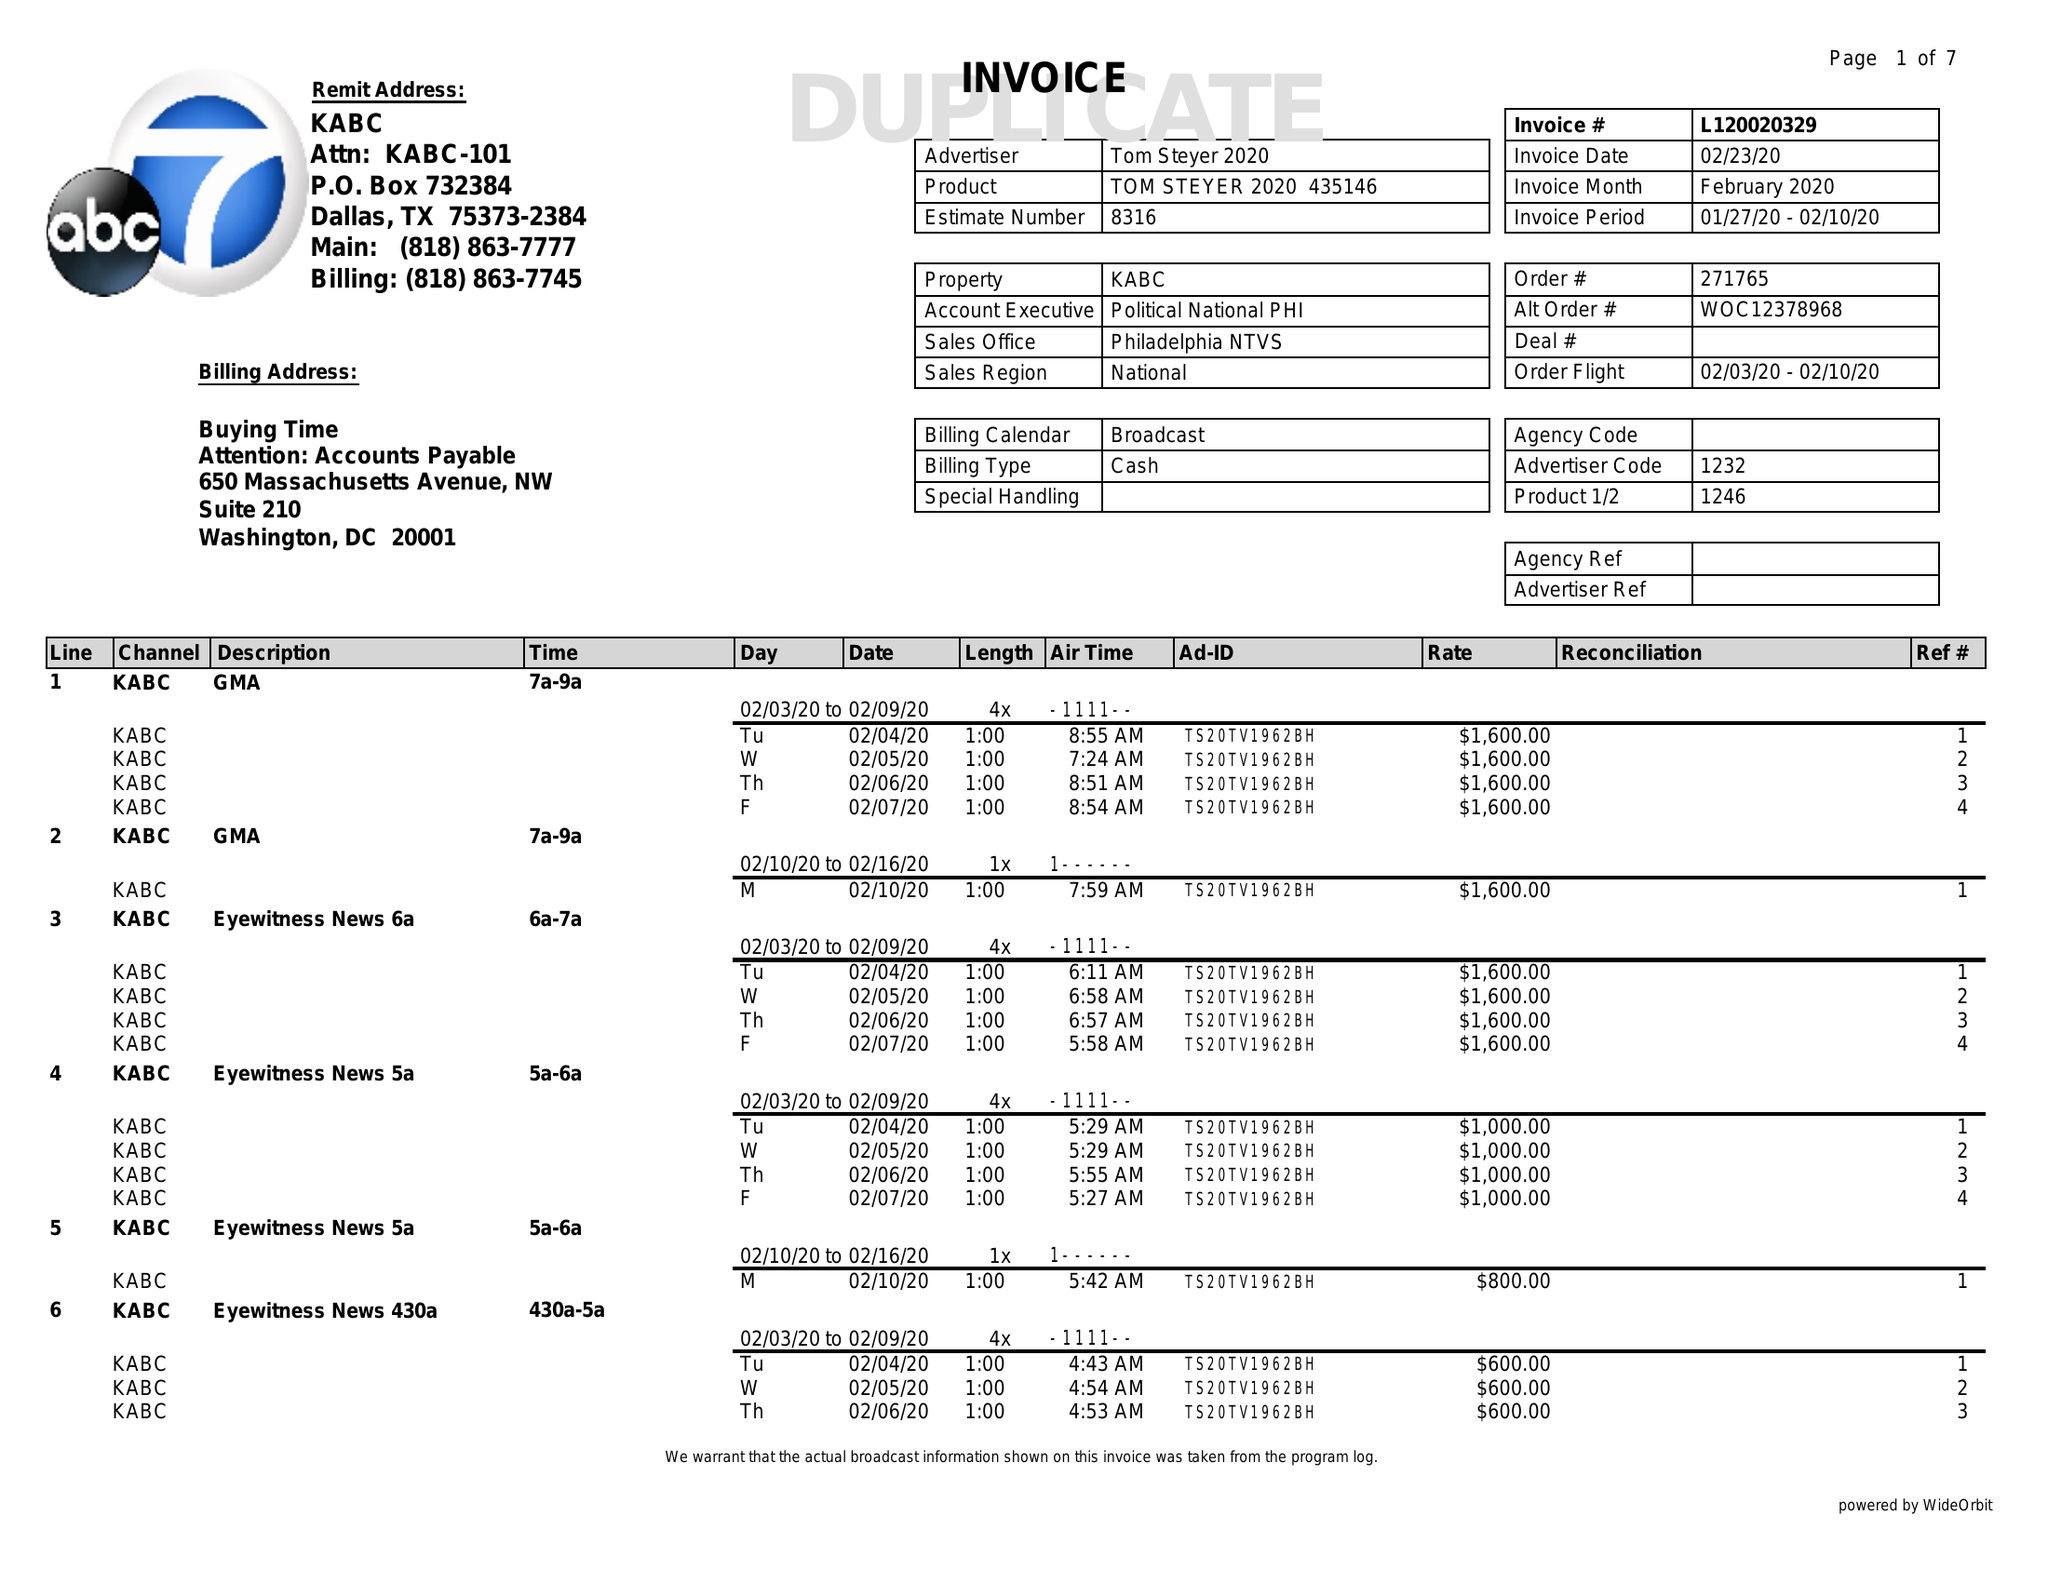What is the value for the contract_num?
Answer the question using a single word or phrase. L120020329 